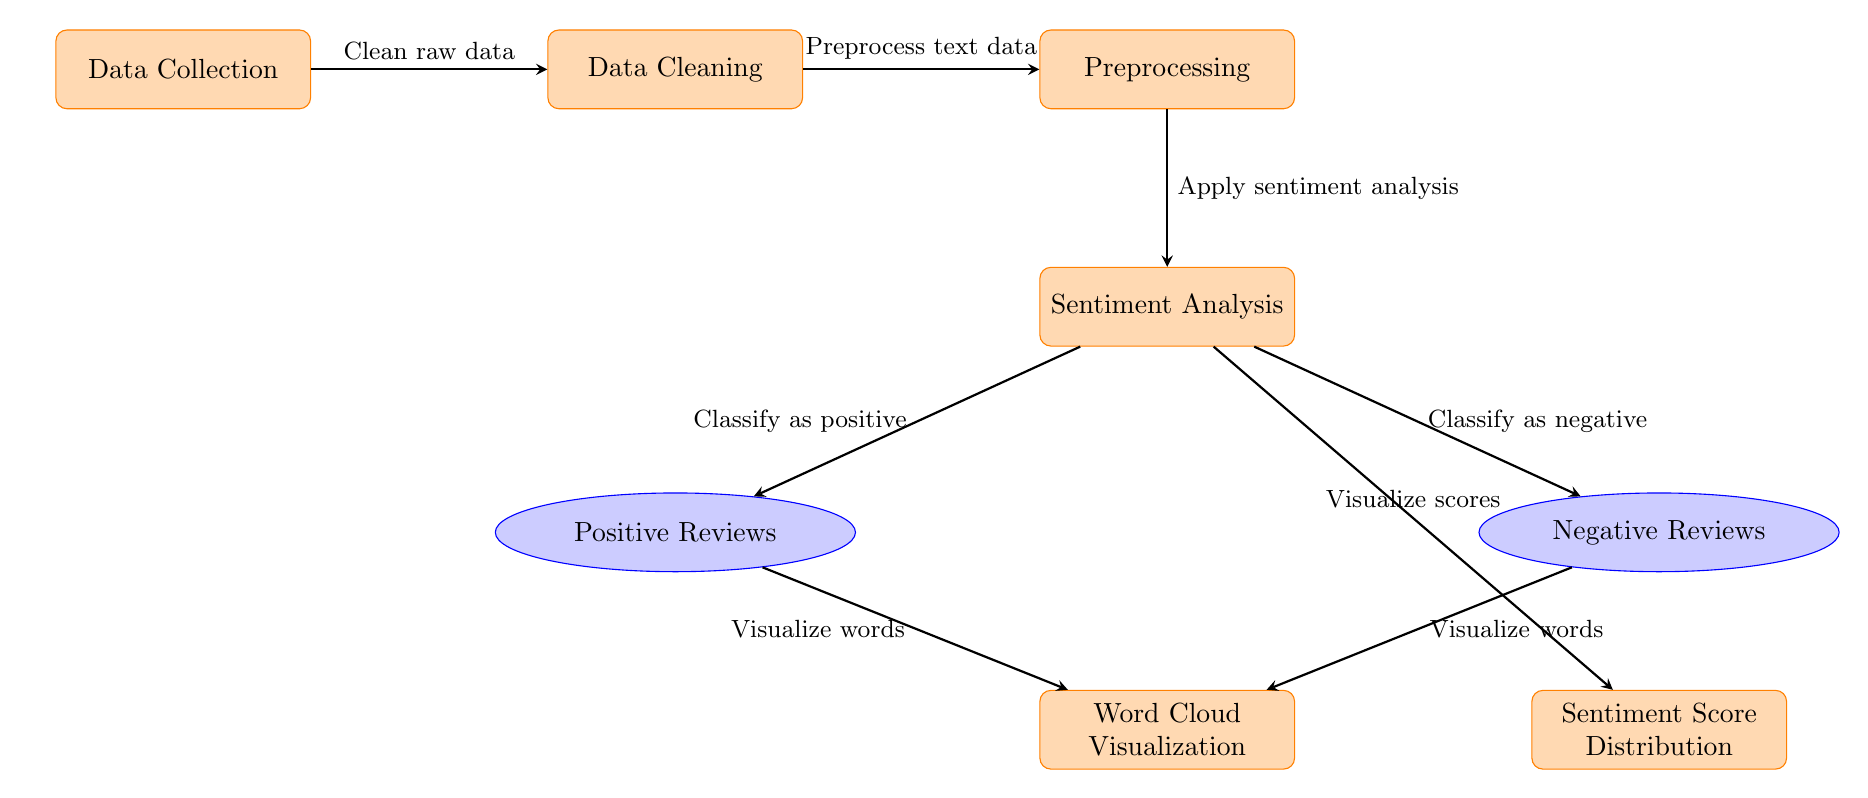What is the first process in the diagram? The first process is labeled as "Data Collection," which is the starting point for the analysis workflow.
Answer: Data Collection How many types of reviews are categorized in the diagram? The diagram specifies two types of reviews: Positive Reviews and Negative Reviews, visually representing the outcomes of the sentiment analysis.
Answer: Two What visualizations are produced in the final steps? The final steps include two visualizations: Word Cloud Visualization and Sentiment Score Distribution, which illustrate the analysis results.
Answer: Word Cloud Visualization and Sentiment Score Distribution Which process directly follows data cleaning? The process that follows data cleaning is labeled "Preprocessing," indicating that data must be prepped for further analysis.
Answer: Preprocessing What action is taken after sentiment analysis? After sentiment analysis, the results are classified into Positive Reviews and Negative Reviews, demonstrating the direction of data flow based on the analysis outcomes.
Answer: Classify as positive and Classify as negative What do the arrows in the diagram represent? The arrows represent the flow of processes and data through the machine learning workflow, indicating the progression from one step to the next.
Answer: Flow of processes and data How are positive and negative reviews visualized? Both Positive Reviews and Negative Reviews are visualized through the Word Cloud Visualization, which merges their contents.
Answer: Word Cloud Visualization What is the purpose of the preprocessing step? The purpose of the preprocessing step is to prepare the text data for sentiment analysis by cleaning or transforming the input data.
Answer: Prepare the text data What is the last step in the sentiment analysis process? The last step in the sentiment analysis process is labeled "Sentiment Score Distribution," which provides a numerical visualization of the review sentiments.
Answer: Sentiment Score Distribution 